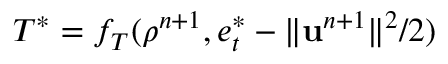<formula> <loc_0><loc_0><loc_500><loc_500>T ^ { * } = f _ { T } ( \rho ^ { n + 1 } , e _ { t } ^ { * } - \| u ^ { n + 1 } \| ^ { 2 } / 2 )</formula> 